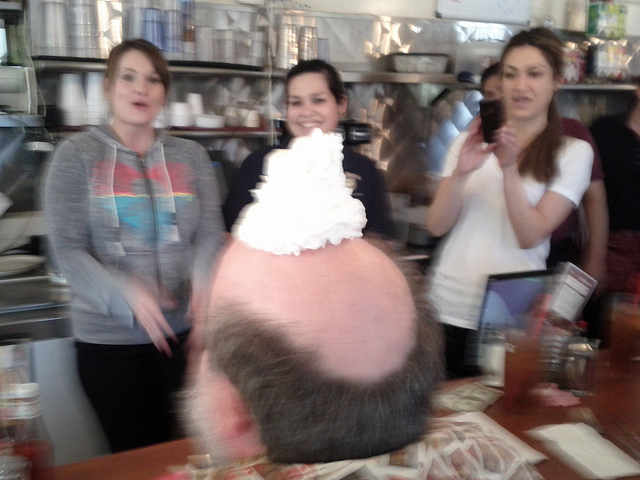Can you describe the atmosphere or emotional vibe of this setting? The atmosphere in the image seems quite convivial and spirited. The blurry movement, the wide smiles, and the playful act of placing whipped cream on someone's head convey a sense of merriment and spontaneity. It's the kind of warm, laughter-filled environment one might find at a jovial gathering or a light-hearted celebration among acquaintances. 